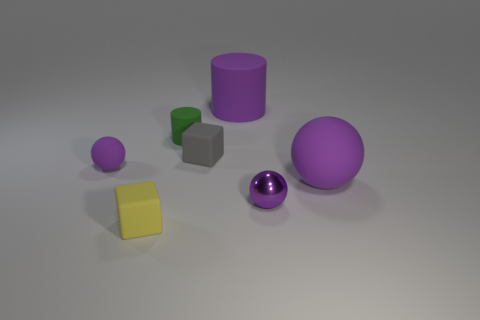Is the number of tiny yellow rubber blocks to the right of the gray object less than the number of tiny matte objects in front of the tiny shiny object?
Provide a succinct answer. Yes. Are there any other things that are the same shape as the tiny yellow object?
Keep it short and to the point. Yes. There is another large matte object that is the same shape as the green thing; what is its color?
Ensure brevity in your answer.  Purple. Do the yellow object and the large rubber object right of the small metallic ball have the same shape?
Provide a succinct answer. No. What number of objects are big rubber things that are behind the tiny cylinder or big things that are behind the small cylinder?
Keep it short and to the point. 1. What number of other things are there of the same size as the purple metal thing?
Your response must be concise. 4. There is a matte block that is on the left side of the green thing; how big is it?
Provide a succinct answer. Small. What is the material of the cube in front of the ball on the left side of the cylinder that is behind the green rubber cylinder?
Provide a succinct answer. Rubber. Is the shape of the tiny yellow matte object the same as the gray rubber object?
Provide a succinct answer. Yes. How many rubber things are either small objects or big purple spheres?
Offer a terse response. 5. 